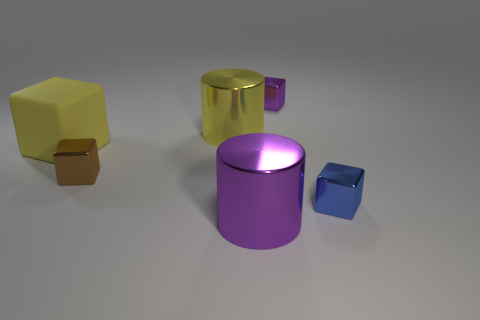Subtract all small blue cubes. How many cubes are left? 3 Subtract all blue cubes. How many cubes are left? 3 Subtract 1 cubes. How many cubes are left? 3 Add 1 red metal cylinders. How many objects exist? 7 Subtract all green cubes. Subtract all yellow cylinders. How many cubes are left? 4 Subtract all yellow cubes. Subtract all cylinders. How many objects are left? 3 Add 5 blue objects. How many blue objects are left? 6 Add 3 big blocks. How many big blocks exist? 4 Subtract 0 green spheres. How many objects are left? 6 Subtract all blocks. How many objects are left? 2 